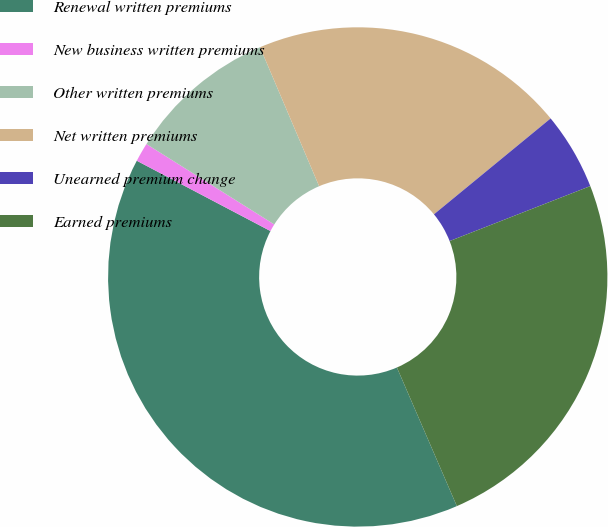<chart> <loc_0><loc_0><loc_500><loc_500><pie_chart><fcel>Renewal written premiums<fcel>New business written premiums<fcel>Other written premiums<fcel>Net written premiums<fcel>Unearned premium change<fcel>Earned premiums<nl><fcel>39.2%<fcel>1.23%<fcel>9.66%<fcel>20.45%<fcel>5.02%<fcel>24.43%<nl></chart> 